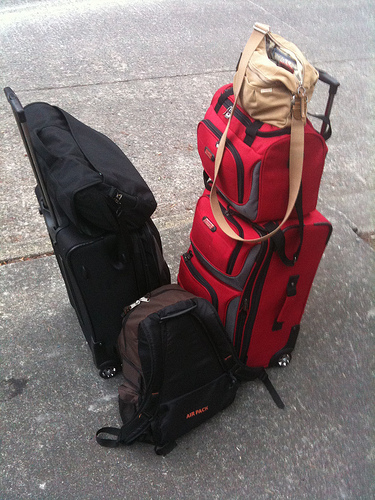Please provide a short description for this region: [0.31, 0.57, 0.69, 0.91]. The visible section contains a brown book bag, partially obscured, appearing robust with a utilitarian design, suitable for serious outdoor or academic use. 